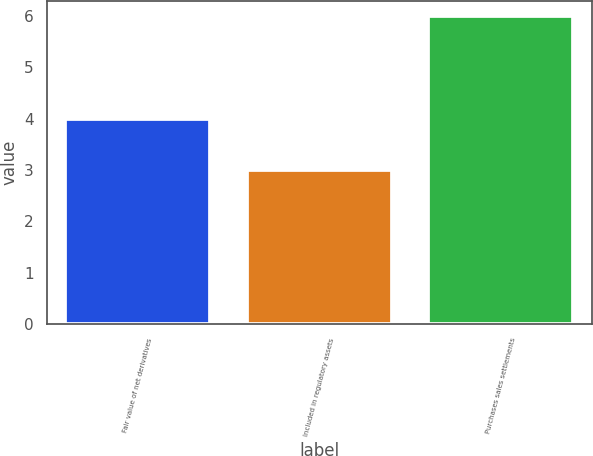<chart> <loc_0><loc_0><loc_500><loc_500><bar_chart><fcel>Fair value of net derivatives<fcel>Included in regulatory assets<fcel>Purchases sales settlements<nl><fcel>4<fcel>3<fcel>6<nl></chart> 